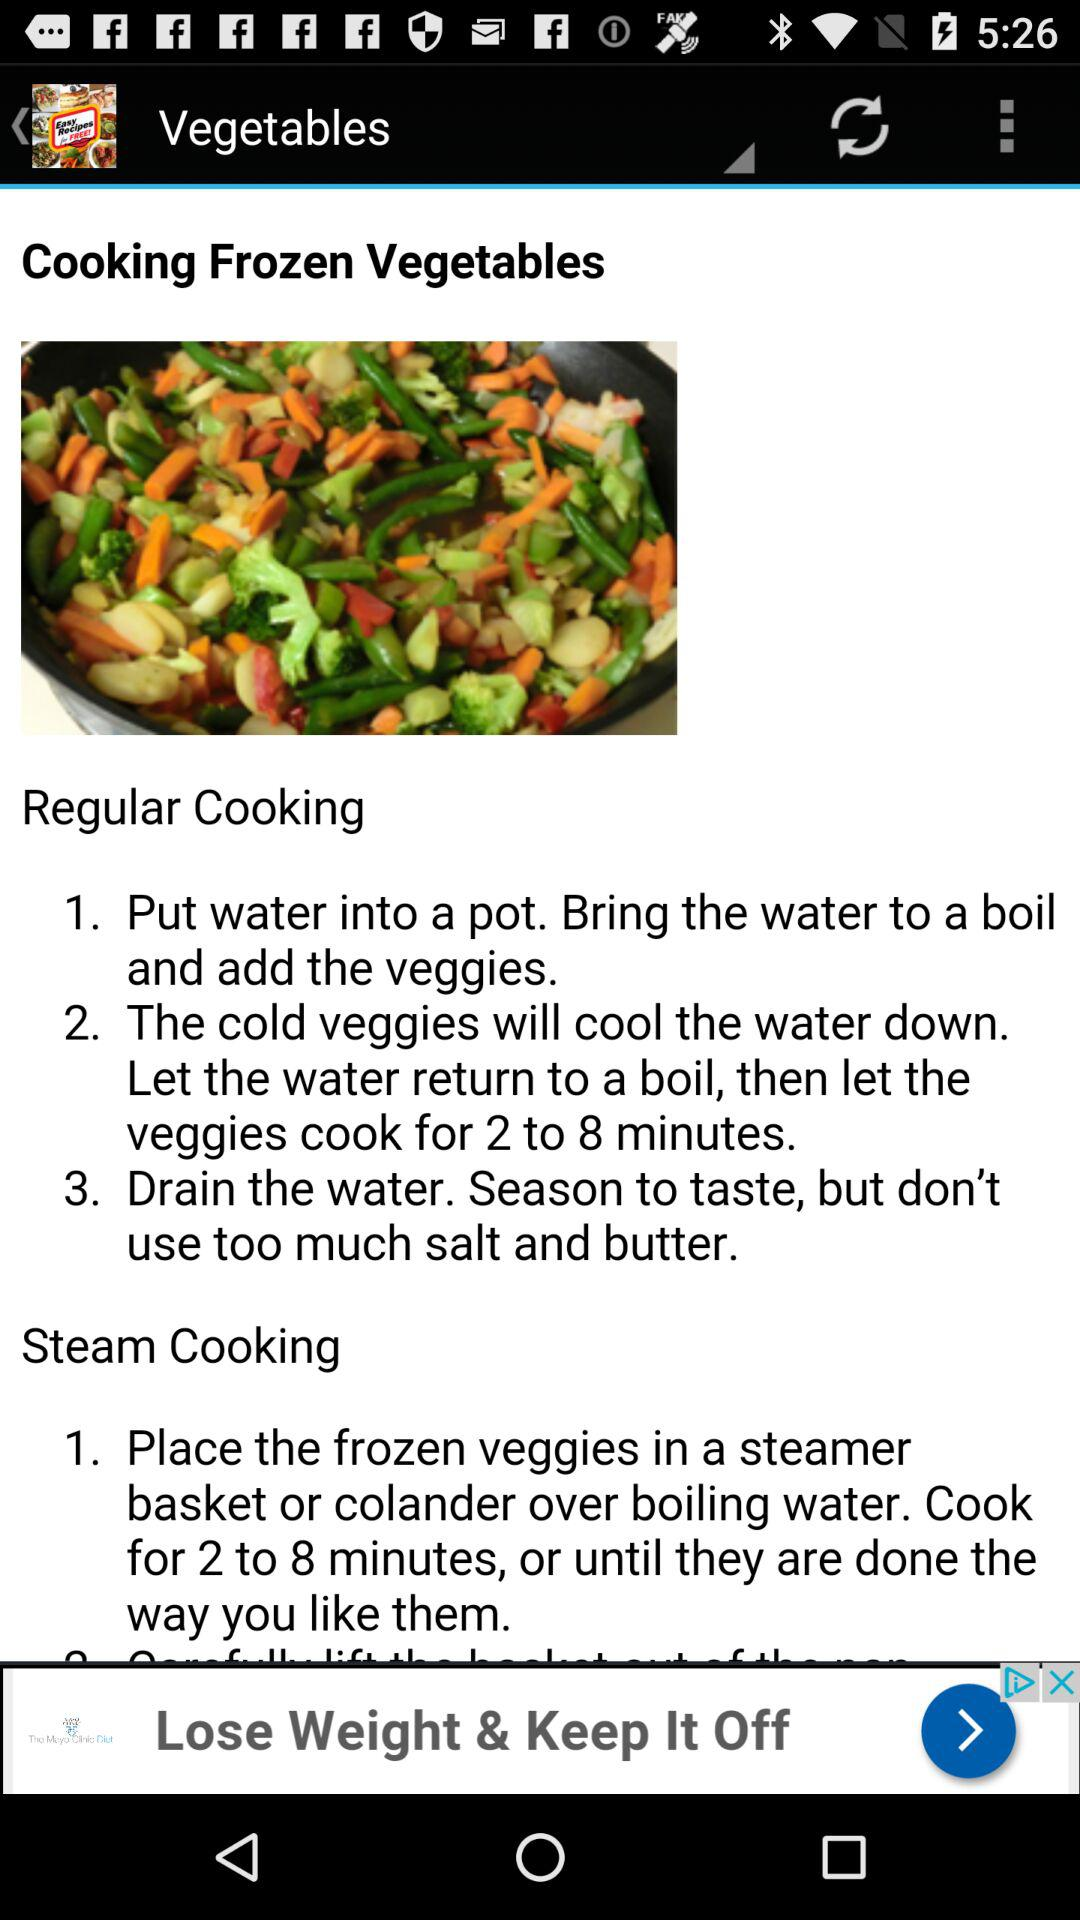What is the recipe for regular cooking? The recipe for regular cooking is "1. Put water into a pot. Bring the water to a boil and add the veggies.", "2. The cold veggies will cool the water down. Let the water return to a boil, then let the veggies cook for 2 to 8 minutes." and "3. Drain the water. Season to taste, but don't use too much salt and butter.". 